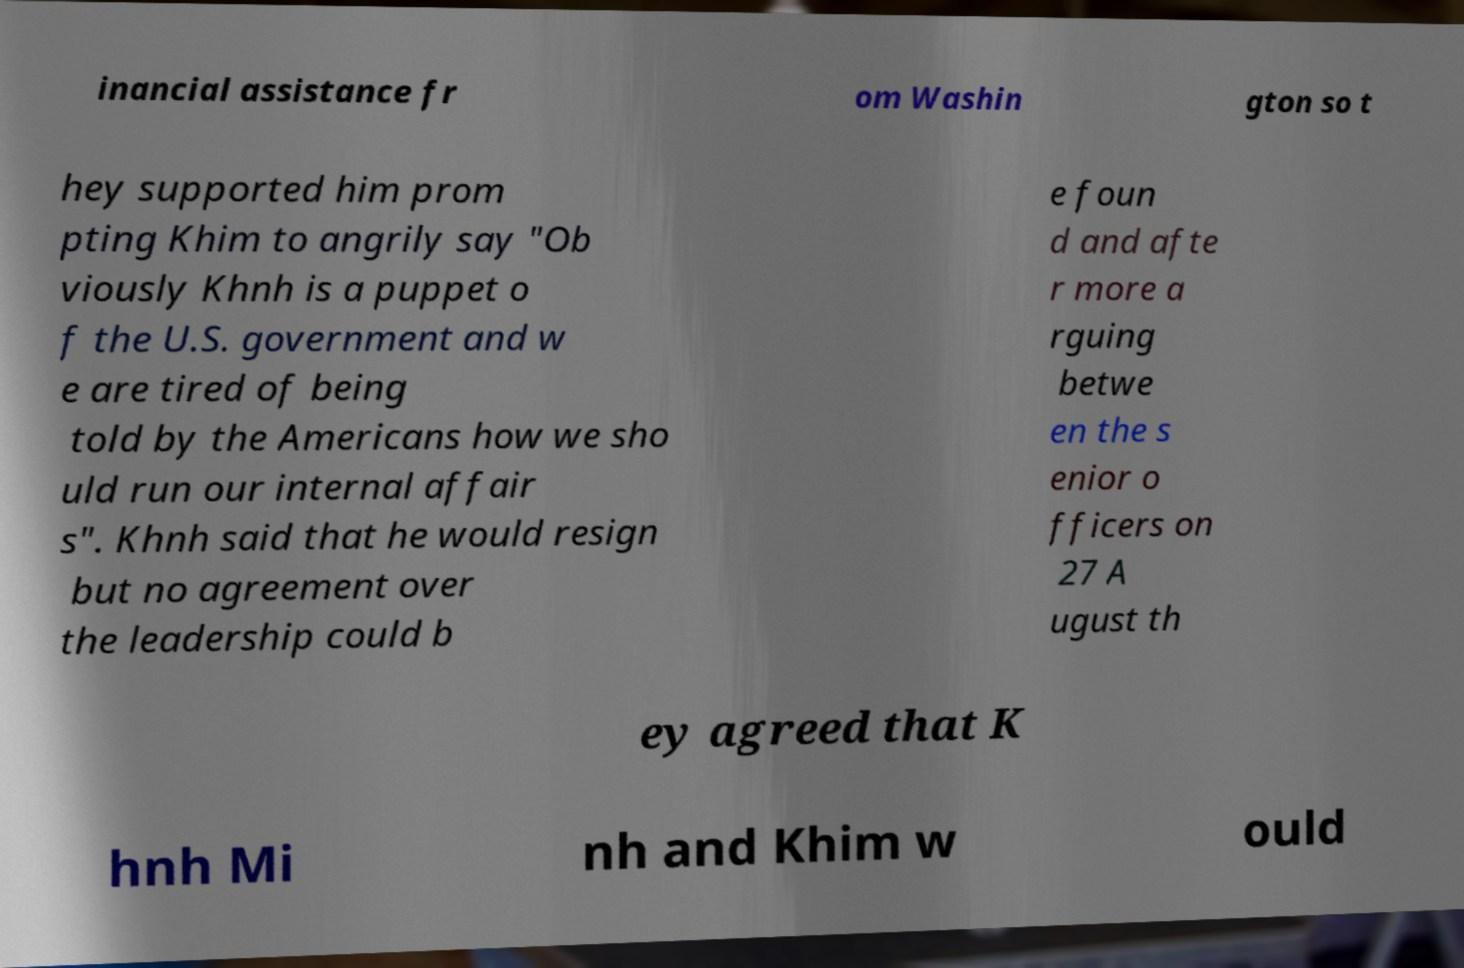I need the written content from this picture converted into text. Can you do that? inancial assistance fr om Washin gton so t hey supported him prom pting Khim to angrily say "Ob viously Khnh is a puppet o f the U.S. government and w e are tired of being told by the Americans how we sho uld run our internal affair s". Khnh said that he would resign but no agreement over the leadership could b e foun d and afte r more a rguing betwe en the s enior o fficers on 27 A ugust th ey agreed that K hnh Mi nh and Khim w ould 